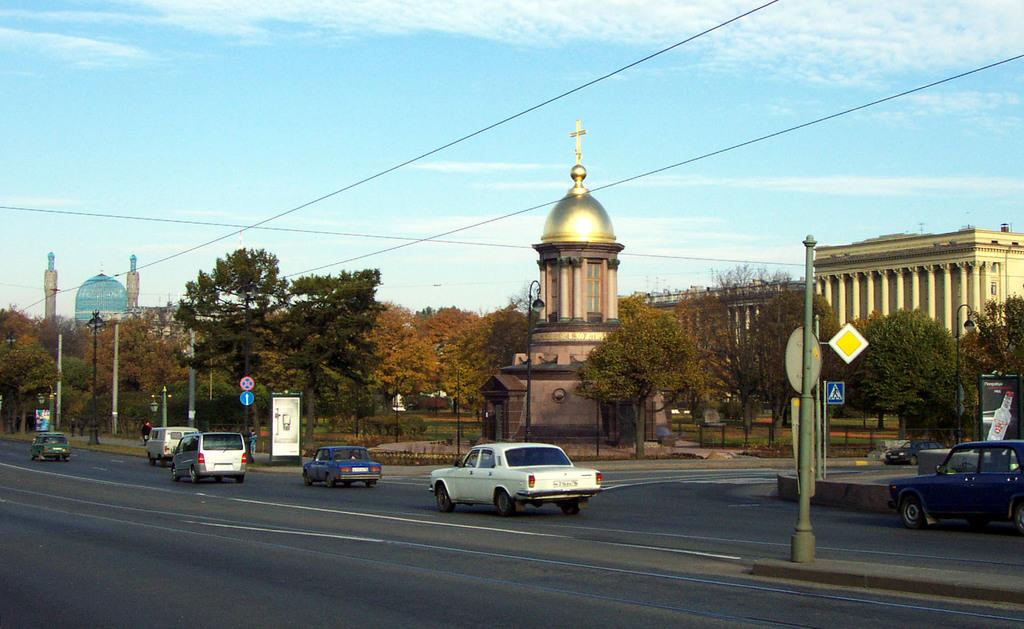What type of structures can be seen in the image? There are buildings in the image. What other natural elements are present in the image? There are trees in the image. What mode of transportation can be seen on the road in the image? Vehicles are present on the road in the image. What are the poles used for in the image? The poles are likely used for supporting wires or other infrastructure. What is visible in the background of the image? The sky is visible in the background of the image. How many goats are grazing under the trees in the image? There are no goats present in the image; it features buildings trees vehicles poles and the sky. How many babies are visible in the image? There are no babies present in the image. 